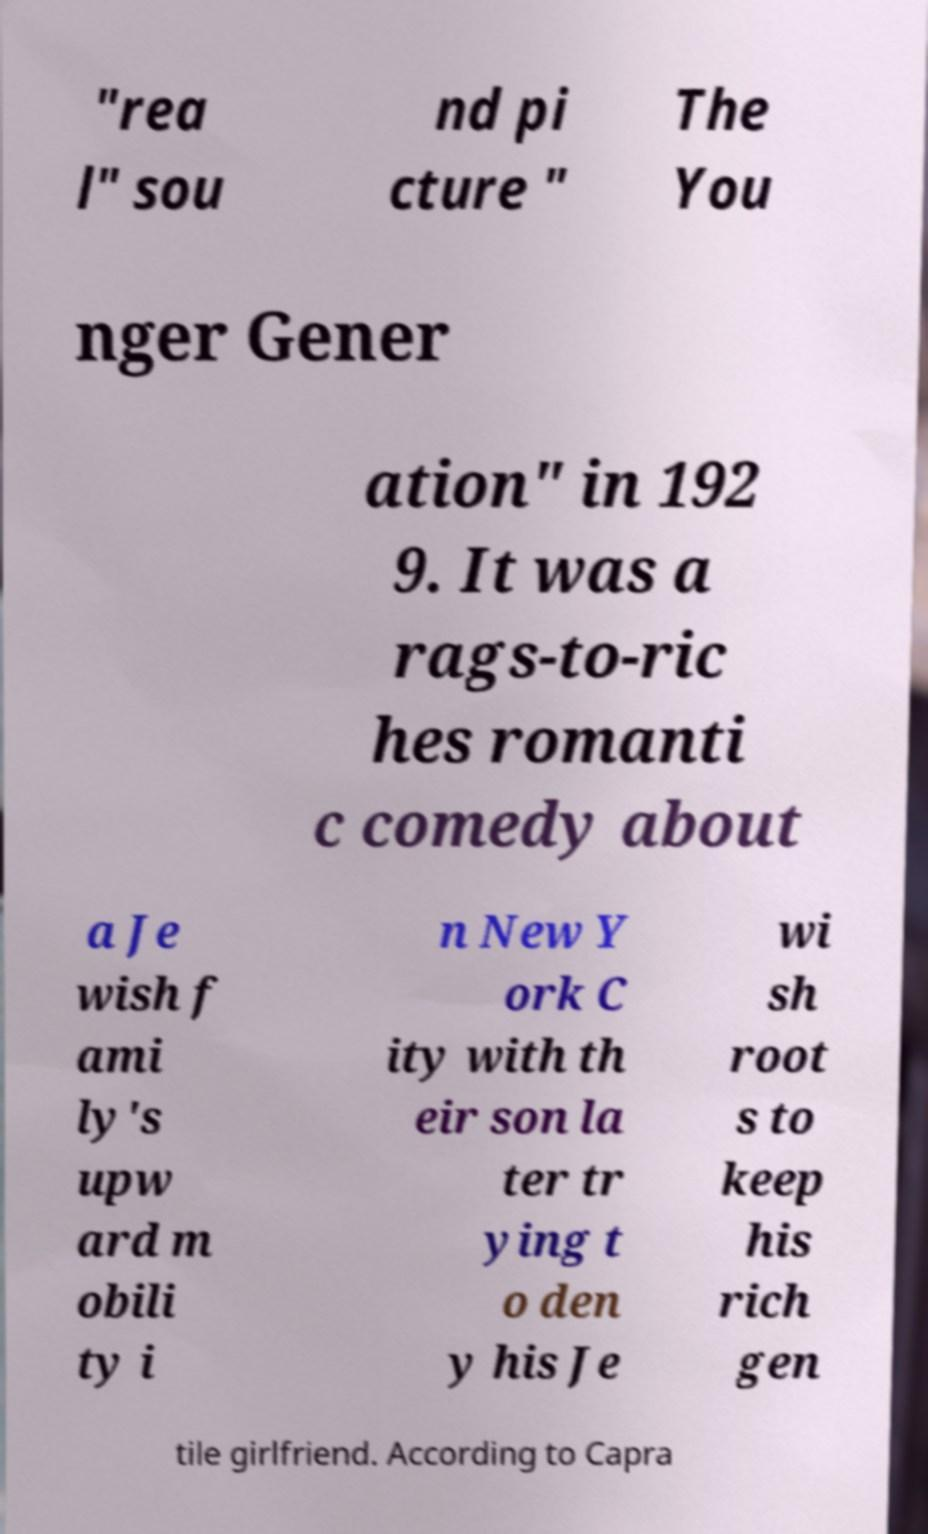Can you accurately transcribe the text from the provided image for me? "rea l" sou nd pi cture " The You nger Gener ation" in 192 9. It was a rags-to-ric hes romanti c comedy about a Je wish f ami ly's upw ard m obili ty i n New Y ork C ity with th eir son la ter tr ying t o den y his Je wi sh root s to keep his rich gen tile girlfriend. According to Capra 